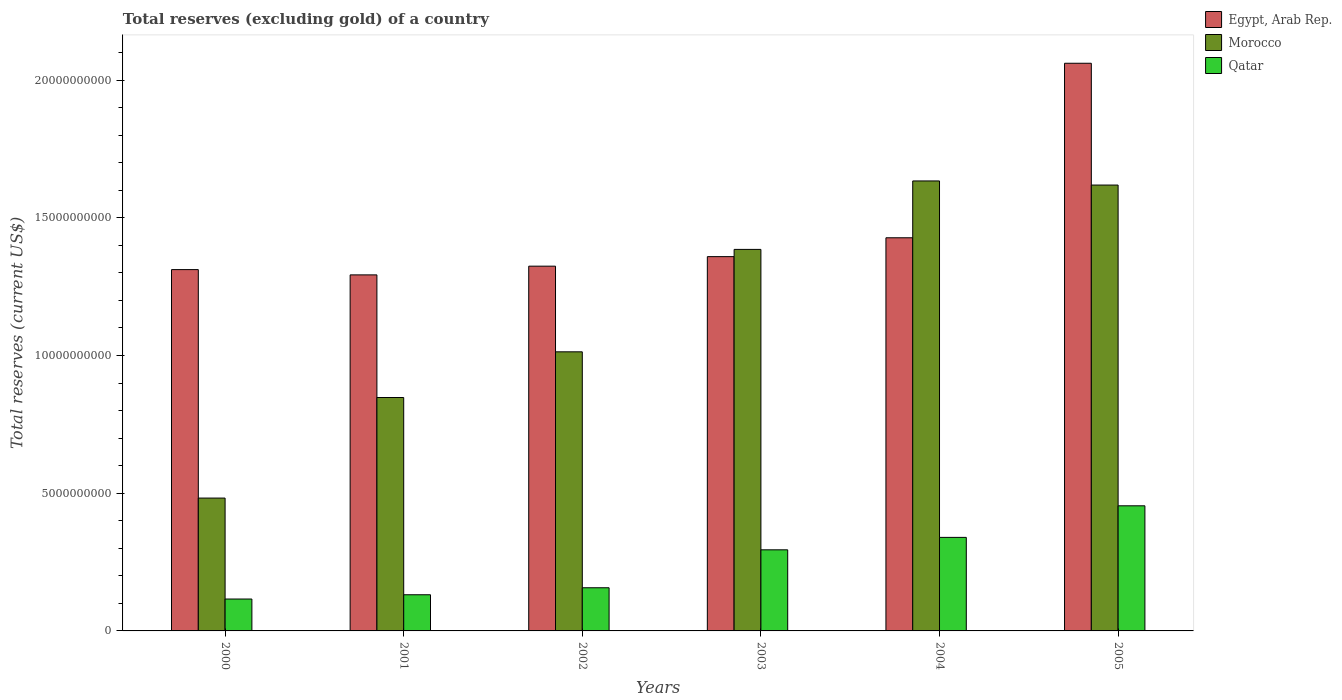How many different coloured bars are there?
Keep it short and to the point. 3. Are the number of bars on each tick of the X-axis equal?
Give a very brief answer. Yes. How many bars are there on the 4th tick from the left?
Your answer should be compact. 3. How many bars are there on the 1st tick from the right?
Keep it short and to the point. 3. In how many cases, is the number of bars for a given year not equal to the number of legend labels?
Your answer should be very brief. 0. What is the total reserves (excluding gold) in Egypt, Arab Rep. in 2005?
Provide a succinct answer. 2.06e+1. Across all years, what is the maximum total reserves (excluding gold) in Qatar?
Provide a succinct answer. 4.54e+09. Across all years, what is the minimum total reserves (excluding gold) in Qatar?
Your answer should be very brief. 1.16e+09. In which year was the total reserves (excluding gold) in Qatar minimum?
Provide a succinct answer. 2000. What is the total total reserves (excluding gold) in Qatar in the graph?
Offer a terse response. 1.49e+1. What is the difference between the total reserves (excluding gold) in Qatar in 2000 and that in 2003?
Ensure brevity in your answer.  -1.79e+09. What is the difference between the total reserves (excluding gold) in Egypt, Arab Rep. in 2000 and the total reserves (excluding gold) in Qatar in 2002?
Provide a short and direct response. 1.16e+1. What is the average total reserves (excluding gold) in Egypt, Arab Rep. per year?
Give a very brief answer. 1.46e+1. In the year 2001, what is the difference between the total reserves (excluding gold) in Qatar and total reserves (excluding gold) in Morocco?
Provide a succinct answer. -7.16e+09. What is the ratio of the total reserves (excluding gold) in Egypt, Arab Rep. in 2001 to that in 2003?
Your answer should be very brief. 0.95. What is the difference between the highest and the second highest total reserves (excluding gold) in Egypt, Arab Rep.?
Offer a terse response. 6.34e+09. What is the difference between the highest and the lowest total reserves (excluding gold) in Qatar?
Make the answer very short. 3.38e+09. Is the sum of the total reserves (excluding gold) in Morocco in 2003 and 2004 greater than the maximum total reserves (excluding gold) in Qatar across all years?
Provide a short and direct response. Yes. What does the 2nd bar from the left in 2003 represents?
Give a very brief answer. Morocco. What does the 1st bar from the right in 2003 represents?
Make the answer very short. Qatar. Is it the case that in every year, the sum of the total reserves (excluding gold) in Morocco and total reserves (excluding gold) in Qatar is greater than the total reserves (excluding gold) in Egypt, Arab Rep.?
Your answer should be very brief. No. How are the legend labels stacked?
Ensure brevity in your answer.  Vertical. What is the title of the graph?
Ensure brevity in your answer.  Total reserves (excluding gold) of a country. What is the label or title of the X-axis?
Make the answer very short. Years. What is the label or title of the Y-axis?
Your answer should be compact. Total reserves (current US$). What is the Total reserves (current US$) of Egypt, Arab Rep. in 2000?
Your answer should be compact. 1.31e+1. What is the Total reserves (current US$) of Morocco in 2000?
Make the answer very short. 4.82e+09. What is the Total reserves (current US$) in Qatar in 2000?
Your answer should be compact. 1.16e+09. What is the Total reserves (current US$) of Egypt, Arab Rep. in 2001?
Offer a terse response. 1.29e+1. What is the Total reserves (current US$) of Morocco in 2001?
Keep it short and to the point. 8.47e+09. What is the Total reserves (current US$) in Qatar in 2001?
Provide a succinct answer. 1.31e+09. What is the Total reserves (current US$) in Egypt, Arab Rep. in 2002?
Ensure brevity in your answer.  1.32e+1. What is the Total reserves (current US$) of Morocco in 2002?
Give a very brief answer. 1.01e+1. What is the Total reserves (current US$) of Qatar in 2002?
Your answer should be very brief. 1.57e+09. What is the Total reserves (current US$) in Egypt, Arab Rep. in 2003?
Offer a very short reply. 1.36e+1. What is the Total reserves (current US$) in Morocco in 2003?
Keep it short and to the point. 1.39e+1. What is the Total reserves (current US$) in Qatar in 2003?
Your response must be concise. 2.94e+09. What is the Total reserves (current US$) in Egypt, Arab Rep. in 2004?
Your answer should be compact. 1.43e+1. What is the Total reserves (current US$) of Morocco in 2004?
Keep it short and to the point. 1.63e+1. What is the Total reserves (current US$) in Qatar in 2004?
Give a very brief answer. 3.40e+09. What is the Total reserves (current US$) in Egypt, Arab Rep. in 2005?
Your answer should be very brief. 2.06e+1. What is the Total reserves (current US$) of Morocco in 2005?
Provide a succinct answer. 1.62e+1. What is the Total reserves (current US$) of Qatar in 2005?
Ensure brevity in your answer.  4.54e+09. Across all years, what is the maximum Total reserves (current US$) in Egypt, Arab Rep.?
Offer a very short reply. 2.06e+1. Across all years, what is the maximum Total reserves (current US$) of Morocco?
Provide a succinct answer. 1.63e+1. Across all years, what is the maximum Total reserves (current US$) of Qatar?
Your answer should be very brief. 4.54e+09. Across all years, what is the minimum Total reserves (current US$) in Egypt, Arab Rep.?
Make the answer very short. 1.29e+1. Across all years, what is the minimum Total reserves (current US$) of Morocco?
Make the answer very short. 4.82e+09. Across all years, what is the minimum Total reserves (current US$) in Qatar?
Provide a succinct answer. 1.16e+09. What is the total Total reserves (current US$) of Egypt, Arab Rep. in the graph?
Offer a very short reply. 8.78e+1. What is the total Total reserves (current US$) in Morocco in the graph?
Give a very brief answer. 6.98e+1. What is the total Total reserves (current US$) of Qatar in the graph?
Keep it short and to the point. 1.49e+1. What is the difference between the Total reserves (current US$) in Egypt, Arab Rep. in 2000 and that in 2001?
Make the answer very short. 1.92e+08. What is the difference between the Total reserves (current US$) of Morocco in 2000 and that in 2001?
Provide a succinct answer. -3.65e+09. What is the difference between the Total reserves (current US$) of Qatar in 2000 and that in 2001?
Offer a very short reply. -1.55e+08. What is the difference between the Total reserves (current US$) in Egypt, Arab Rep. in 2000 and that in 2002?
Offer a very short reply. -1.25e+08. What is the difference between the Total reserves (current US$) in Morocco in 2000 and that in 2002?
Provide a short and direct response. -5.31e+09. What is the difference between the Total reserves (current US$) of Qatar in 2000 and that in 2002?
Your response must be concise. -4.09e+08. What is the difference between the Total reserves (current US$) of Egypt, Arab Rep. in 2000 and that in 2003?
Provide a short and direct response. -4.71e+08. What is the difference between the Total reserves (current US$) of Morocco in 2000 and that in 2003?
Offer a very short reply. -9.03e+09. What is the difference between the Total reserves (current US$) in Qatar in 2000 and that in 2003?
Keep it short and to the point. -1.79e+09. What is the difference between the Total reserves (current US$) in Egypt, Arab Rep. in 2000 and that in 2004?
Keep it short and to the point. -1.16e+09. What is the difference between the Total reserves (current US$) of Morocco in 2000 and that in 2004?
Make the answer very short. -1.15e+1. What is the difference between the Total reserves (current US$) of Qatar in 2000 and that in 2004?
Provide a short and direct response. -2.24e+09. What is the difference between the Total reserves (current US$) of Egypt, Arab Rep. in 2000 and that in 2005?
Offer a very short reply. -7.49e+09. What is the difference between the Total reserves (current US$) in Morocco in 2000 and that in 2005?
Your response must be concise. -1.14e+1. What is the difference between the Total reserves (current US$) in Qatar in 2000 and that in 2005?
Provide a succinct answer. -3.38e+09. What is the difference between the Total reserves (current US$) of Egypt, Arab Rep. in 2001 and that in 2002?
Provide a short and direct response. -3.17e+08. What is the difference between the Total reserves (current US$) of Morocco in 2001 and that in 2002?
Your answer should be compact. -1.66e+09. What is the difference between the Total reserves (current US$) of Qatar in 2001 and that in 2002?
Your answer should be compact. -2.54e+08. What is the difference between the Total reserves (current US$) of Egypt, Arab Rep. in 2001 and that in 2003?
Offer a very short reply. -6.63e+08. What is the difference between the Total reserves (current US$) of Morocco in 2001 and that in 2003?
Give a very brief answer. -5.38e+09. What is the difference between the Total reserves (current US$) of Qatar in 2001 and that in 2003?
Give a very brief answer. -1.63e+09. What is the difference between the Total reserves (current US$) in Egypt, Arab Rep. in 2001 and that in 2004?
Give a very brief answer. -1.35e+09. What is the difference between the Total reserves (current US$) of Morocco in 2001 and that in 2004?
Ensure brevity in your answer.  -7.86e+09. What is the difference between the Total reserves (current US$) of Qatar in 2001 and that in 2004?
Make the answer very short. -2.08e+09. What is the difference between the Total reserves (current US$) in Egypt, Arab Rep. in 2001 and that in 2005?
Provide a short and direct response. -7.68e+09. What is the difference between the Total reserves (current US$) in Morocco in 2001 and that in 2005?
Your response must be concise. -7.71e+09. What is the difference between the Total reserves (current US$) of Qatar in 2001 and that in 2005?
Keep it short and to the point. -3.23e+09. What is the difference between the Total reserves (current US$) in Egypt, Arab Rep. in 2002 and that in 2003?
Offer a very short reply. -3.46e+08. What is the difference between the Total reserves (current US$) in Morocco in 2002 and that in 2003?
Provide a succinct answer. -3.72e+09. What is the difference between the Total reserves (current US$) of Qatar in 2002 and that in 2003?
Give a very brief answer. -1.38e+09. What is the difference between the Total reserves (current US$) in Egypt, Arab Rep. in 2002 and that in 2004?
Provide a short and direct response. -1.03e+09. What is the difference between the Total reserves (current US$) of Morocco in 2002 and that in 2004?
Provide a succinct answer. -6.20e+09. What is the difference between the Total reserves (current US$) of Qatar in 2002 and that in 2004?
Keep it short and to the point. -1.83e+09. What is the difference between the Total reserves (current US$) in Egypt, Arab Rep. in 2002 and that in 2005?
Offer a very short reply. -7.37e+09. What is the difference between the Total reserves (current US$) of Morocco in 2002 and that in 2005?
Ensure brevity in your answer.  -6.05e+09. What is the difference between the Total reserves (current US$) in Qatar in 2002 and that in 2005?
Your answer should be compact. -2.98e+09. What is the difference between the Total reserves (current US$) of Egypt, Arab Rep. in 2003 and that in 2004?
Ensure brevity in your answer.  -6.84e+08. What is the difference between the Total reserves (current US$) in Morocco in 2003 and that in 2004?
Your response must be concise. -2.49e+09. What is the difference between the Total reserves (current US$) in Qatar in 2003 and that in 2004?
Your answer should be compact. -4.52e+08. What is the difference between the Total reserves (current US$) in Egypt, Arab Rep. in 2003 and that in 2005?
Give a very brief answer. -7.02e+09. What is the difference between the Total reserves (current US$) in Morocco in 2003 and that in 2005?
Your response must be concise. -2.34e+09. What is the difference between the Total reserves (current US$) of Qatar in 2003 and that in 2005?
Offer a very short reply. -1.60e+09. What is the difference between the Total reserves (current US$) in Egypt, Arab Rep. in 2004 and that in 2005?
Make the answer very short. -6.34e+09. What is the difference between the Total reserves (current US$) in Morocco in 2004 and that in 2005?
Keep it short and to the point. 1.49e+08. What is the difference between the Total reserves (current US$) in Qatar in 2004 and that in 2005?
Keep it short and to the point. -1.15e+09. What is the difference between the Total reserves (current US$) of Egypt, Arab Rep. in 2000 and the Total reserves (current US$) of Morocco in 2001?
Your answer should be very brief. 4.64e+09. What is the difference between the Total reserves (current US$) in Egypt, Arab Rep. in 2000 and the Total reserves (current US$) in Qatar in 2001?
Offer a very short reply. 1.18e+1. What is the difference between the Total reserves (current US$) in Morocco in 2000 and the Total reserves (current US$) in Qatar in 2001?
Ensure brevity in your answer.  3.51e+09. What is the difference between the Total reserves (current US$) of Egypt, Arab Rep. in 2000 and the Total reserves (current US$) of Morocco in 2002?
Provide a short and direct response. 2.98e+09. What is the difference between the Total reserves (current US$) in Egypt, Arab Rep. in 2000 and the Total reserves (current US$) in Qatar in 2002?
Make the answer very short. 1.16e+1. What is the difference between the Total reserves (current US$) in Morocco in 2000 and the Total reserves (current US$) in Qatar in 2002?
Make the answer very short. 3.26e+09. What is the difference between the Total reserves (current US$) of Egypt, Arab Rep. in 2000 and the Total reserves (current US$) of Morocco in 2003?
Ensure brevity in your answer.  -7.34e+08. What is the difference between the Total reserves (current US$) of Egypt, Arab Rep. in 2000 and the Total reserves (current US$) of Qatar in 2003?
Offer a terse response. 1.02e+1. What is the difference between the Total reserves (current US$) of Morocco in 2000 and the Total reserves (current US$) of Qatar in 2003?
Ensure brevity in your answer.  1.88e+09. What is the difference between the Total reserves (current US$) of Egypt, Arab Rep. in 2000 and the Total reserves (current US$) of Morocco in 2004?
Provide a succinct answer. -3.22e+09. What is the difference between the Total reserves (current US$) of Egypt, Arab Rep. in 2000 and the Total reserves (current US$) of Qatar in 2004?
Ensure brevity in your answer.  9.72e+09. What is the difference between the Total reserves (current US$) in Morocco in 2000 and the Total reserves (current US$) in Qatar in 2004?
Give a very brief answer. 1.43e+09. What is the difference between the Total reserves (current US$) of Egypt, Arab Rep. in 2000 and the Total reserves (current US$) of Morocco in 2005?
Keep it short and to the point. -3.07e+09. What is the difference between the Total reserves (current US$) of Egypt, Arab Rep. in 2000 and the Total reserves (current US$) of Qatar in 2005?
Keep it short and to the point. 8.58e+09. What is the difference between the Total reserves (current US$) in Morocco in 2000 and the Total reserves (current US$) in Qatar in 2005?
Keep it short and to the point. 2.81e+08. What is the difference between the Total reserves (current US$) of Egypt, Arab Rep. in 2001 and the Total reserves (current US$) of Morocco in 2002?
Offer a terse response. 2.79e+09. What is the difference between the Total reserves (current US$) of Egypt, Arab Rep. in 2001 and the Total reserves (current US$) of Qatar in 2002?
Give a very brief answer. 1.14e+1. What is the difference between the Total reserves (current US$) of Morocco in 2001 and the Total reserves (current US$) of Qatar in 2002?
Provide a succinct answer. 6.91e+09. What is the difference between the Total reserves (current US$) of Egypt, Arab Rep. in 2001 and the Total reserves (current US$) of Morocco in 2003?
Your response must be concise. -9.25e+08. What is the difference between the Total reserves (current US$) in Egypt, Arab Rep. in 2001 and the Total reserves (current US$) in Qatar in 2003?
Keep it short and to the point. 9.98e+09. What is the difference between the Total reserves (current US$) of Morocco in 2001 and the Total reserves (current US$) of Qatar in 2003?
Ensure brevity in your answer.  5.53e+09. What is the difference between the Total reserves (current US$) in Egypt, Arab Rep. in 2001 and the Total reserves (current US$) in Morocco in 2004?
Your answer should be very brief. -3.41e+09. What is the difference between the Total reserves (current US$) of Egypt, Arab Rep. in 2001 and the Total reserves (current US$) of Qatar in 2004?
Your response must be concise. 9.53e+09. What is the difference between the Total reserves (current US$) of Morocco in 2001 and the Total reserves (current US$) of Qatar in 2004?
Offer a terse response. 5.08e+09. What is the difference between the Total reserves (current US$) of Egypt, Arab Rep. in 2001 and the Total reserves (current US$) of Morocco in 2005?
Offer a very short reply. -3.26e+09. What is the difference between the Total reserves (current US$) of Egypt, Arab Rep. in 2001 and the Total reserves (current US$) of Qatar in 2005?
Provide a succinct answer. 8.38e+09. What is the difference between the Total reserves (current US$) in Morocco in 2001 and the Total reserves (current US$) in Qatar in 2005?
Give a very brief answer. 3.93e+09. What is the difference between the Total reserves (current US$) in Egypt, Arab Rep. in 2002 and the Total reserves (current US$) in Morocco in 2003?
Make the answer very short. -6.09e+08. What is the difference between the Total reserves (current US$) of Egypt, Arab Rep. in 2002 and the Total reserves (current US$) of Qatar in 2003?
Your answer should be compact. 1.03e+1. What is the difference between the Total reserves (current US$) in Morocco in 2002 and the Total reserves (current US$) in Qatar in 2003?
Provide a succinct answer. 7.19e+09. What is the difference between the Total reserves (current US$) of Egypt, Arab Rep. in 2002 and the Total reserves (current US$) of Morocco in 2004?
Offer a terse response. -3.09e+09. What is the difference between the Total reserves (current US$) in Egypt, Arab Rep. in 2002 and the Total reserves (current US$) in Qatar in 2004?
Provide a short and direct response. 9.85e+09. What is the difference between the Total reserves (current US$) in Morocco in 2002 and the Total reserves (current US$) in Qatar in 2004?
Keep it short and to the point. 6.74e+09. What is the difference between the Total reserves (current US$) in Egypt, Arab Rep. in 2002 and the Total reserves (current US$) in Morocco in 2005?
Offer a terse response. -2.95e+09. What is the difference between the Total reserves (current US$) in Egypt, Arab Rep. in 2002 and the Total reserves (current US$) in Qatar in 2005?
Provide a short and direct response. 8.70e+09. What is the difference between the Total reserves (current US$) in Morocco in 2002 and the Total reserves (current US$) in Qatar in 2005?
Offer a terse response. 5.59e+09. What is the difference between the Total reserves (current US$) in Egypt, Arab Rep. in 2003 and the Total reserves (current US$) in Morocco in 2004?
Your answer should be compact. -2.75e+09. What is the difference between the Total reserves (current US$) in Egypt, Arab Rep. in 2003 and the Total reserves (current US$) in Qatar in 2004?
Offer a terse response. 1.02e+1. What is the difference between the Total reserves (current US$) in Morocco in 2003 and the Total reserves (current US$) in Qatar in 2004?
Your answer should be very brief. 1.05e+1. What is the difference between the Total reserves (current US$) of Egypt, Arab Rep. in 2003 and the Total reserves (current US$) of Morocco in 2005?
Your response must be concise. -2.60e+09. What is the difference between the Total reserves (current US$) of Egypt, Arab Rep. in 2003 and the Total reserves (current US$) of Qatar in 2005?
Make the answer very short. 9.05e+09. What is the difference between the Total reserves (current US$) of Morocco in 2003 and the Total reserves (current US$) of Qatar in 2005?
Your response must be concise. 9.31e+09. What is the difference between the Total reserves (current US$) in Egypt, Arab Rep. in 2004 and the Total reserves (current US$) in Morocco in 2005?
Ensure brevity in your answer.  -1.91e+09. What is the difference between the Total reserves (current US$) in Egypt, Arab Rep. in 2004 and the Total reserves (current US$) in Qatar in 2005?
Ensure brevity in your answer.  9.73e+09. What is the difference between the Total reserves (current US$) of Morocco in 2004 and the Total reserves (current US$) of Qatar in 2005?
Give a very brief answer. 1.18e+1. What is the average Total reserves (current US$) in Egypt, Arab Rep. per year?
Give a very brief answer. 1.46e+1. What is the average Total reserves (current US$) of Morocco per year?
Your answer should be compact. 1.16e+1. What is the average Total reserves (current US$) in Qatar per year?
Provide a short and direct response. 2.49e+09. In the year 2000, what is the difference between the Total reserves (current US$) in Egypt, Arab Rep. and Total reserves (current US$) in Morocco?
Keep it short and to the point. 8.29e+09. In the year 2000, what is the difference between the Total reserves (current US$) of Egypt, Arab Rep. and Total reserves (current US$) of Qatar?
Your answer should be compact. 1.20e+1. In the year 2000, what is the difference between the Total reserves (current US$) of Morocco and Total reserves (current US$) of Qatar?
Offer a very short reply. 3.67e+09. In the year 2001, what is the difference between the Total reserves (current US$) of Egypt, Arab Rep. and Total reserves (current US$) of Morocco?
Make the answer very short. 4.45e+09. In the year 2001, what is the difference between the Total reserves (current US$) in Egypt, Arab Rep. and Total reserves (current US$) in Qatar?
Offer a very short reply. 1.16e+1. In the year 2001, what is the difference between the Total reserves (current US$) of Morocco and Total reserves (current US$) of Qatar?
Provide a succinct answer. 7.16e+09. In the year 2002, what is the difference between the Total reserves (current US$) in Egypt, Arab Rep. and Total reserves (current US$) in Morocco?
Keep it short and to the point. 3.11e+09. In the year 2002, what is the difference between the Total reserves (current US$) of Egypt, Arab Rep. and Total reserves (current US$) of Qatar?
Offer a very short reply. 1.17e+1. In the year 2002, what is the difference between the Total reserves (current US$) in Morocco and Total reserves (current US$) in Qatar?
Your answer should be compact. 8.57e+09. In the year 2003, what is the difference between the Total reserves (current US$) in Egypt, Arab Rep. and Total reserves (current US$) in Morocco?
Keep it short and to the point. -2.62e+08. In the year 2003, what is the difference between the Total reserves (current US$) in Egypt, Arab Rep. and Total reserves (current US$) in Qatar?
Make the answer very short. 1.06e+1. In the year 2003, what is the difference between the Total reserves (current US$) in Morocco and Total reserves (current US$) in Qatar?
Offer a terse response. 1.09e+1. In the year 2004, what is the difference between the Total reserves (current US$) of Egypt, Arab Rep. and Total reserves (current US$) of Morocco?
Your answer should be compact. -2.06e+09. In the year 2004, what is the difference between the Total reserves (current US$) of Egypt, Arab Rep. and Total reserves (current US$) of Qatar?
Your answer should be very brief. 1.09e+1. In the year 2004, what is the difference between the Total reserves (current US$) of Morocco and Total reserves (current US$) of Qatar?
Offer a terse response. 1.29e+1. In the year 2005, what is the difference between the Total reserves (current US$) in Egypt, Arab Rep. and Total reserves (current US$) in Morocco?
Your answer should be compact. 4.42e+09. In the year 2005, what is the difference between the Total reserves (current US$) in Egypt, Arab Rep. and Total reserves (current US$) in Qatar?
Give a very brief answer. 1.61e+1. In the year 2005, what is the difference between the Total reserves (current US$) of Morocco and Total reserves (current US$) of Qatar?
Ensure brevity in your answer.  1.16e+1. What is the ratio of the Total reserves (current US$) in Egypt, Arab Rep. in 2000 to that in 2001?
Your answer should be very brief. 1.01. What is the ratio of the Total reserves (current US$) in Morocco in 2000 to that in 2001?
Provide a short and direct response. 0.57. What is the ratio of the Total reserves (current US$) of Qatar in 2000 to that in 2001?
Your answer should be compact. 0.88. What is the ratio of the Total reserves (current US$) of Egypt, Arab Rep. in 2000 to that in 2002?
Provide a succinct answer. 0.99. What is the ratio of the Total reserves (current US$) of Morocco in 2000 to that in 2002?
Offer a terse response. 0.48. What is the ratio of the Total reserves (current US$) of Qatar in 2000 to that in 2002?
Your response must be concise. 0.74. What is the ratio of the Total reserves (current US$) in Egypt, Arab Rep. in 2000 to that in 2003?
Keep it short and to the point. 0.97. What is the ratio of the Total reserves (current US$) in Morocco in 2000 to that in 2003?
Provide a succinct answer. 0.35. What is the ratio of the Total reserves (current US$) of Qatar in 2000 to that in 2003?
Ensure brevity in your answer.  0.39. What is the ratio of the Total reserves (current US$) in Egypt, Arab Rep. in 2000 to that in 2004?
Ensure brevity in your answer.  0.92. What is the ratio of the Total reserves (current US$) of Morocco in 2000 to that in 2004?
Give a very brief answer. 0.3. What is the ratio of the Total reserves (current US$) of Qatar in 2000 to that in 2004?
Your answer should be compact. 0.34. What is the ratio of the Total reserves (current US$) of Egypt, Arab Rep. in 2000 to that in 2005?
Give a very brief answer. 0.64. What is the ratio of the Total reserves (current US$) in Morocco in 2000 to that in 2005?
Offer a very short reply. 0.3. What is the ratio of the Total reserves (current US$) in Qatar in 2000 to that in 2005?
Your response must be concise. 0.25. What is the ratio of the Total reserves (current US$) of Egypt, Arab Rep. in 2001 to that in 2002?
Keep it short and to the point. 0.98. What is the ratio of the Total reserves (current US$) in Morocco in 2001 to that in 2002?
Keep it short and to the point. 0.84. What is the ratio of the Total reserves (current US$) in Qatar in 2001 to that in 2002?
Give a very brief answer. 0.84. What is the ratio of the Total reserves (current US$) in Egypt, Arab Rep. in 2001 to that in 2003?
Keep it short and to the point. 0.95. What is the ratio of the Total reserves (current US$) in Morocco in 2001 to that in 2003?
Your response must be concise. 0.61. What is the ratio of the Total reserves (current US$) in Qatar in 2001 to that in 2003?
Offer a very short reply. 0.45. What is the ratio of the Total reserves (current US$) in Egypt, Arab Rep. in 2001 to that in 2004?
Your response must be concise. 0.91. What is the ratio of the Total reserves (current US$) of Morocco in 2001 to that in 2004?
Your answer should be compact. 0.52. What is the ratio of the Total reserves (current US$) of Qatar in 2001 to that in 2004?
Provide a succinct answer. 0.39. What is the ratio of the Total reserves (current US$) of Egypt, Arab Rep. in 2001 to that in 2005?
Offer a very short reply. 0.63. What is the ratio of the Total reserves (current US$) in Morocco in 2001 to that in 2005?
Provide a succinct answer. 0.52. What is the ratio of the Total reserves (current US$) of Qatar in 2001 to that in 2005?
Offer a terse response. 0.29. What is the ratio of the Total reserves (current US$) of Egypt, Arab Rep. in 2002 to that in 2003?
Provide a short and direct response. 0.97. What is the ratio of the Total reserves (current US$) of Morocco in 2002 to that in 2003?
Offer a terse response. 0.73. What is the ratio of the Total reserves (current US$) in Qatar in 2002 to that in 2003?
Make the answer very short. 0.53. What is the ratio of the Total reserves (current US$) in Egypt, Arab Rep. in 2002 to that in 2004?
Keep it short and to the point. 0.93. What is the ratio of the Total reserves (current US$) in Morocco in 2002 to that in 2004?
Provide a succinct answer. 0.62. What is the ratio of the Total reserves (current US$) in Qatar in 2002 to that in 2004?
Offer a very short reply. 0.46. What is the ratio of the Total reserves (current US$) of Egypt, Arab Rep. in 2002 to that in 2005?
Your answer should be very brief. 0.64. What is the ratio of the Total reserves (current US$) in Morocco in 2002 to that in 2005?
Ensure brevity in your answer.  0.63. What is the ratio of the Total reserves (current US$) of Qatar in 2002 to that in 2005?
Your response must be concise. 0.34. What is the ratio of the Total reserves (current US$) of Morocco in 2003 to that in 2004?
Keep it short and to the point. 0.85. What is the ratio of the Total reserves (current US$) in Qatar in 2003 to that in 2004?
Make the answer very short. 0.87. What is the ratio of the Total reserves (current US$) of Egypt, Arab Rep. in 2003 to that in 2005?
Provide a short and direct response. 0.66. What is the ratio of the Total reserves (current US$) in Morocco in 2003 to that in 2005?
Ensure brevity in your answer.  0.86. What is the ratio of the Total reserves (current US$) of Qatar in 2003 to that in 2005?
Ensure brevity in your answer.  0.65. What is the ratio of the Total reserves (current US$) in Egypt, Arab Rep. in 2004 to that in 2005?
Offer a terse response. 0.69. What is the ratio of the Total reserves (current US$) in Morocco in 2004 to that in 2005?
Provide a succinct answer. 1.01. What is the ratio of the Total reserves (current US$) in Qatar in 2004 to that in 2005?
Make the answer very short. 0.75. What is the difference between the highest and the second highest Total reserves (current US$) in Egypt, Arab Rep.?
Your answer should be compact. 6.34e+09. What is the difference between the highest and the second highest Total reserves (current US$) of Morocco?
Your response must be concise. 1.49e+08. What is the difference between the highest and the second highest Total reserves (current US$) of Qatar?
Ensure brevity in your answer.  1.15e+09. What is the difference between the highest and the lowest Total reserves (current US$) of Egypt, Arab Rep.?
Ensure brevity in your answer.  7.68e+09. What is the difference between the highest and the lowest Total reserves (current US$) of Morocco?
Make the answer very short. 1.15e+1. What is the difference between the highest and the lowest Total reserves (current US$) of Qatar?
Provide a short and direct response. 3.38e+09. 